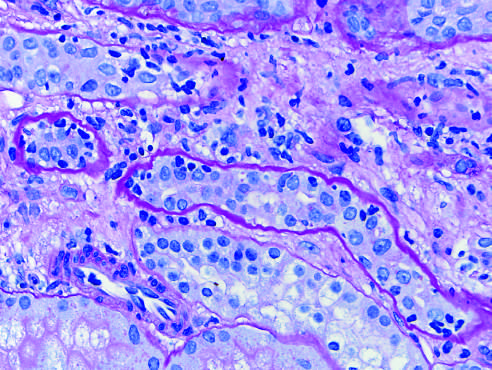what is manifested by inflammatory cells in the inter-stitium and between epithelial cells of the tubules tubulitis?
Answer the question using a single word or phrase. Acute cellular rejection of a kidney graft 